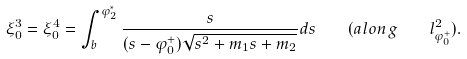Convert formula to latex. <formula><loc_0><loc_0><loc_500><loc_500>\xi _ { 0 } ^ { 3 } = \xi _ { 0 } ^ { 4 } = \int _ { b } ^ { \varphi _ { 2 } ^ { * } } { \frac { s } { ( s - \varphi _ { 0 } ^ { + } ) \sqrt { s ^ { 2 } + m _ { 1 } s + m _ { 2 } } } d s } \quad ( a l o n g \quad l _ { \varphi _ { 0 } ^ { + } } ^ { 2 } ) .</formula> 